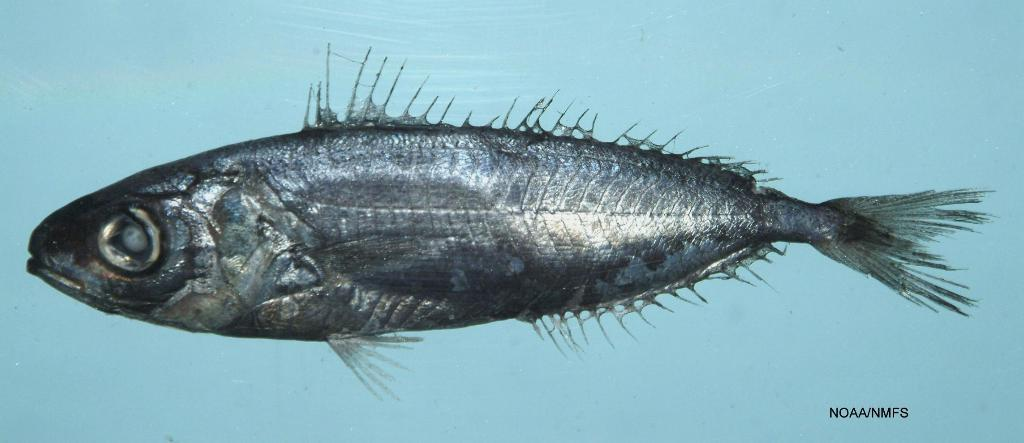What is the main subject of the image? There is a fish in the image. What color is the background of the image? The background of the image is blue. Where is the text located in the image? The text is in the bottom right of the image. What type of yarn is being used to comfort the fish in the image? There is no yarn or indication of comforting the fish in the image. 